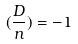Convert formula to latex. <formula><loc_0><loc_0><loc_500><loc_500>( \frac { D } { n } ) = - 1</formula> 